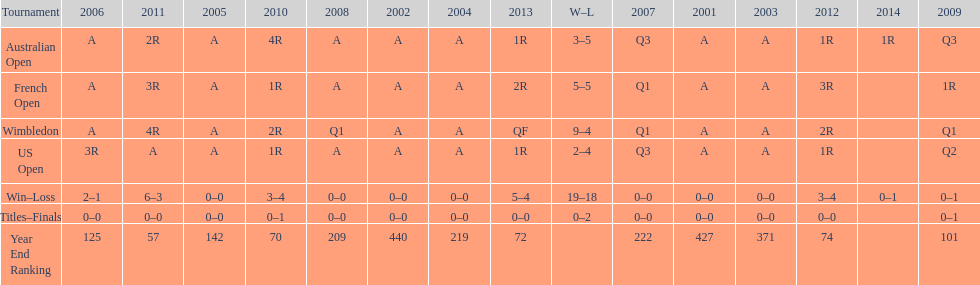Give me the full table as a dictionary. {'header': ['Tournament', '2006', '2011', '2005', '2010', '2008', '2002', '2004', '2013', 'W–L', '2007', '2001', '2003', '2012', '2014', '2009'], 'rows': [['Australian Open', 'A', '2R', 'A', '4R', 'A', 'A', 'A', '1R', '3–5', 'Q3', 'A', 'A', '1R', '1R', 'Q3'], ['French Open', 'A', '3R', 'A', '1R', 'A', 'A', 'A', '2R', '5–5', 'Q1', 'A', 'A', '3R', '', '1R'], ['Wimbledon', 'A', '4R', 'A', '2R', 'Q1', 'A', 'A', 'QF', '9–4', 'Q1', 'A', 'A', '2R', '', 'Q1'], ['US Open', '3R', 'A', 'A', '1R', 'A', 'A', 'A', '1R', '2–4', 'Q3', 'A', 'A', '1R', '', 'Q2'], ['Win–Loss', '2–1', '6–3', '0–0', '3–4', '0–0', '0–0', '0–0', '5–4', '19–18', '0–0', '0–0', '0–0', '3–4', '0–1', '0–1'], ['Titles–Finals', '0–0', '0–0', '0–0', '0–1', '0–0', '0–0', '0–0', '0–0', '0–2', '0–0', '0–0', '0–0', '0–0', '', '0–1'], ['Year End Ranking', '125', '57', '142', '70', '209', '440', '219', '72', '', '222', '427', '371', '74', '', '101']]} In which years was a rank under 200 attained? 2005, 2006, 2009, 2010, 2011, 2012, 2013. 